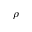Convert formula to latex. <formula><loc_0><loc_0><loc_500><loc_500>\rho</formula> 